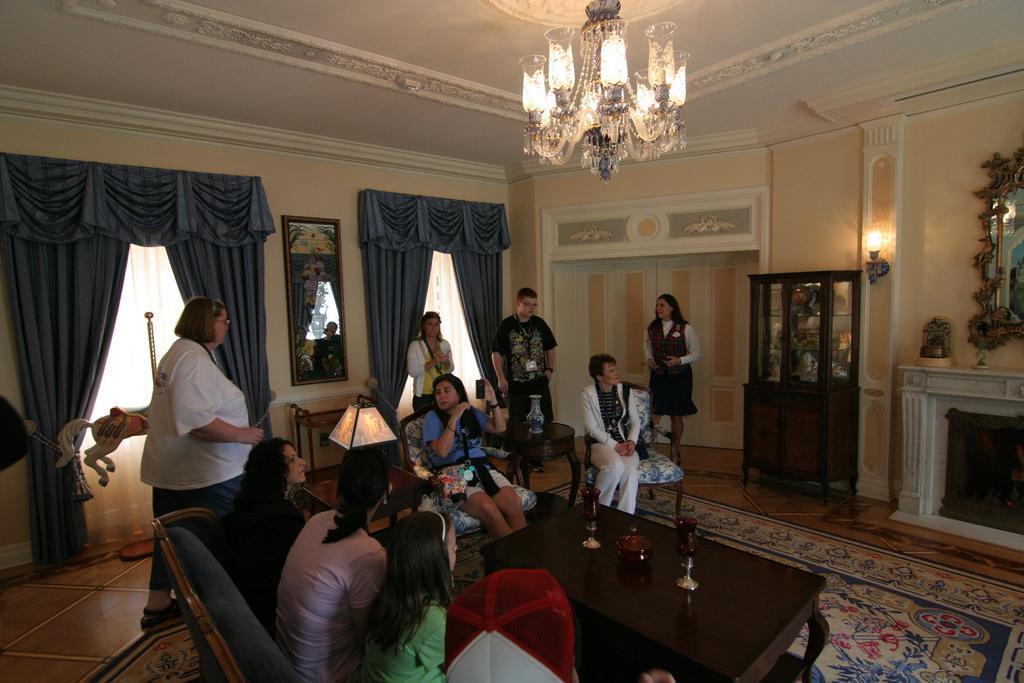Could you give a brief overview of what you see in this image? In this image I can see group of people. Among them some people are sitting in front of the table and some people are standing. On the table there are some of the objects. In the back ground there is a frame to the wall and curtains to the windows and I can also see a chandelier light. 